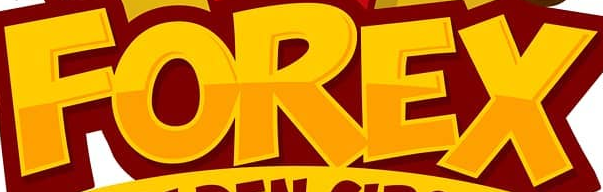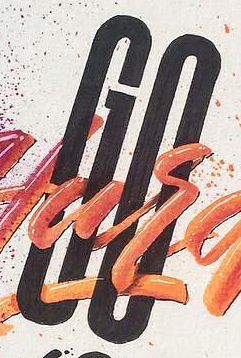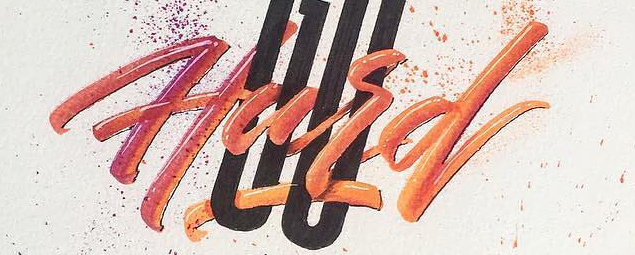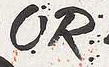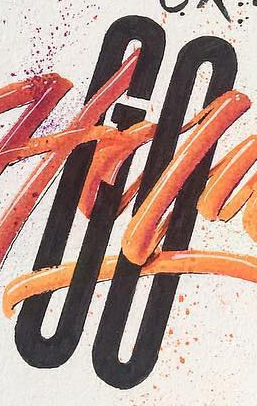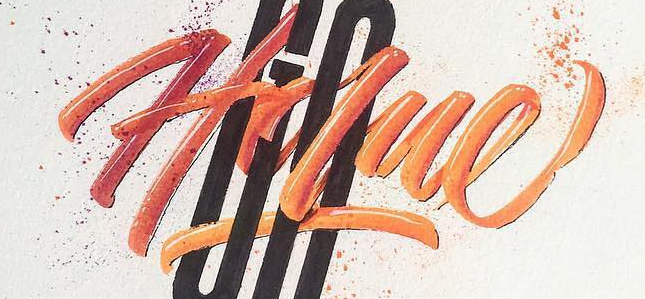What words can you see in these images in sequence, separated by a semicolon? FOREX; GO; Hard; OR; GO; Holue 